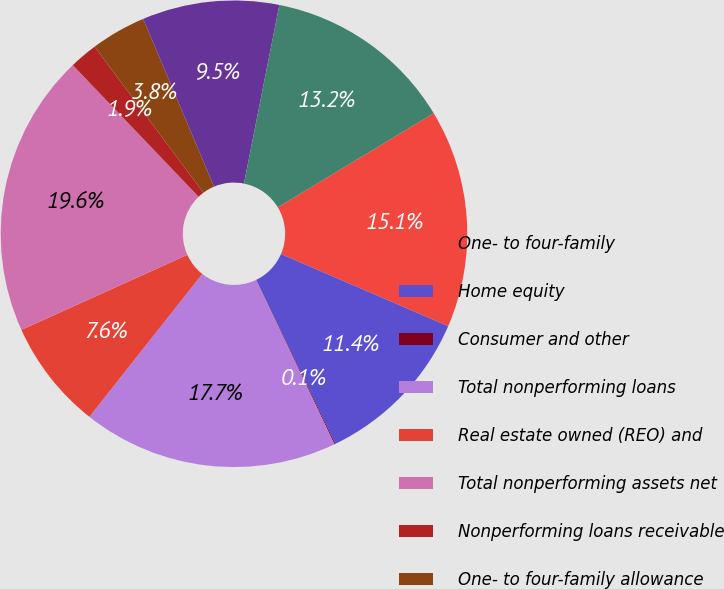<chart> <loc_0><loc_0><loc_500><loc_500><pie_chart><fcel>One- to four-family<fcel>Home equity<fcel>Consumer and other<fcel>Total nonperforming loans<fcel>Real estate owned (REO) and<fcel>Total nonperforming assets net<fcel>Nonperforming loans receivable<fcel>One- to four-family allowance<fcel>Home equity allowance for loan<fcel>Consumer and other allowance<nl><fcel>15.13%<fcel>11.36%<fcel>0.07%<fcel>17.73%<fcel>7.6%<fcel>19.62%<fcel>1.95%<fcel>3.83%<fcel>9.48%<fcel>13.24%<nl></chart> 